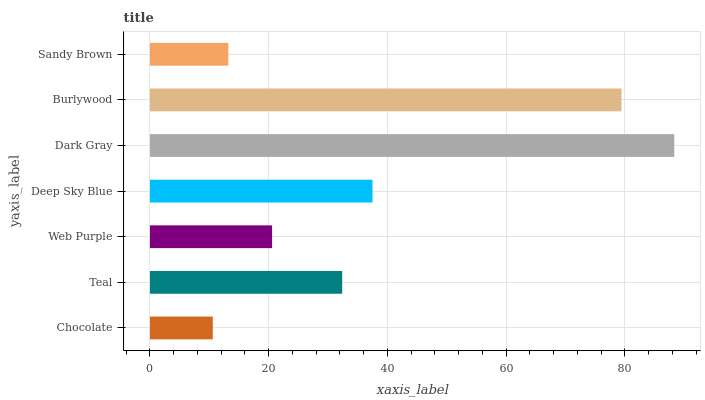Is Chocolate the minimum?
Answer yes or no. Yes. Is Dark Gray the maximum?
Answer yes or no. Yes. Is Teal the minimum?
Answer yes or no. No. Is Teal the maximum?
Answer yes or no. No. Is Teal greater than Chocolate?
Answer yes or no. Yes. Is Chocolate less than Teal?
Answer yes or no. Yes. Is Chocolate greater than Teal?
Answer yes or no. No. Is Teal less than Chocolate?
Answer yes or no. No. Is Teal the high median?
Answer yes or no. Yes. Is Teal the low median?
Answer yes or no. Yes. Is Chocolate the high median?
Answer yes or no. No. Is Burlywood the low median?
Answer yes or no. No. 